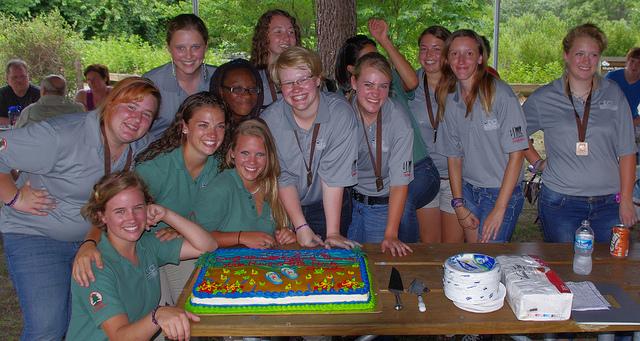What is on the left side of the table?
Be succinct. Cake. Are they happy?
Be succinct. Yes. Is that bottle of water on the table open?
Short answer required. Yes. 